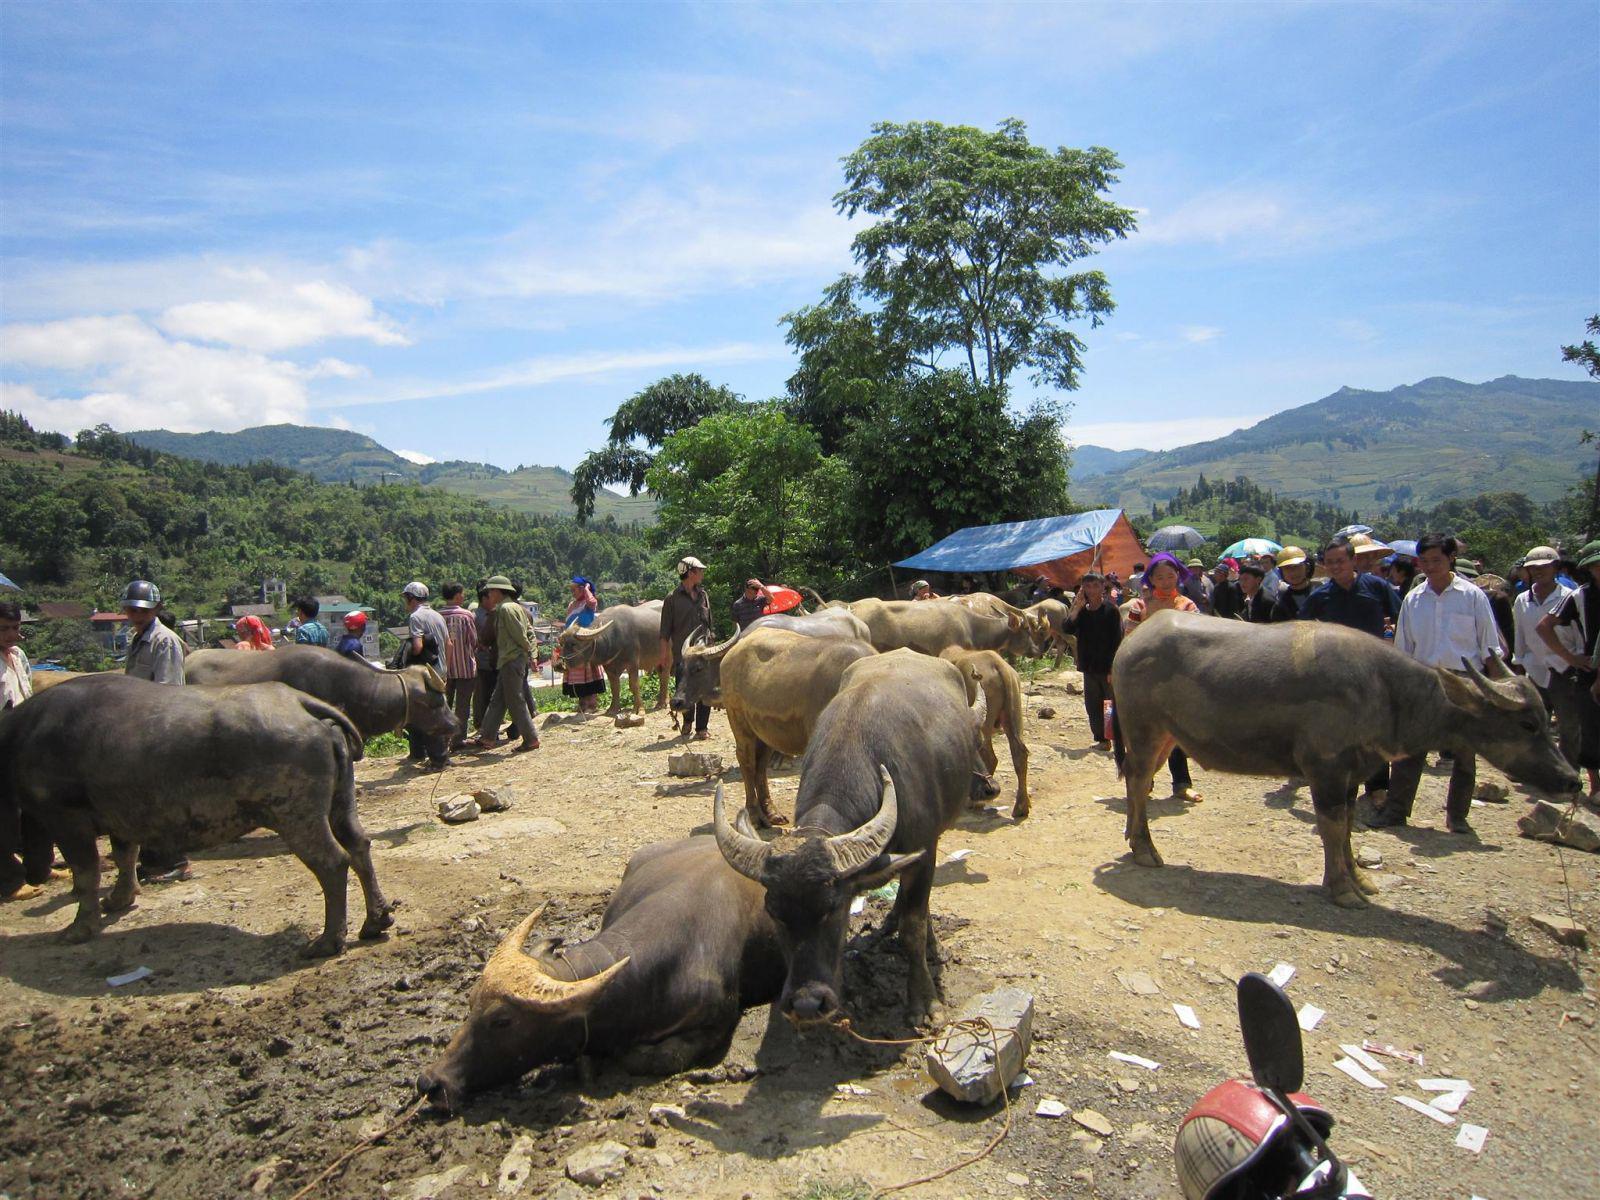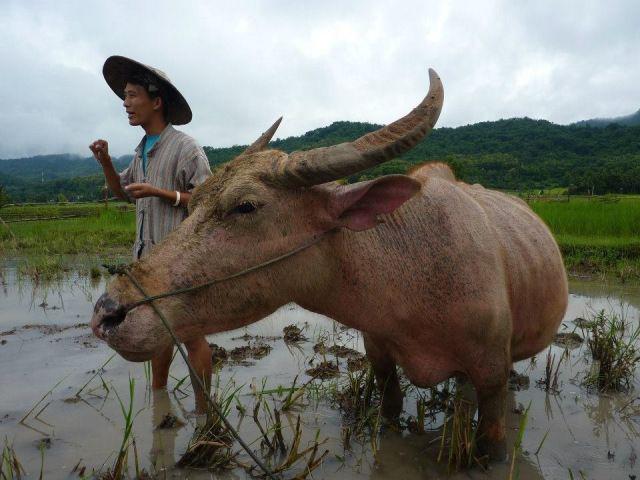The first image is the image on the left, the second image is the image on the right. For the images shown, is this caption "At least one water buffalo is standing in water." true? Answer yes or no. Yes. The first image is the image on the left, the second image is the image on the right. Evaluate the accuracy of this statement regarding the images: "Right image shows one ox with a rope looped through its nose, walking in water.". Is it true? Answer yes or no. Yes. 